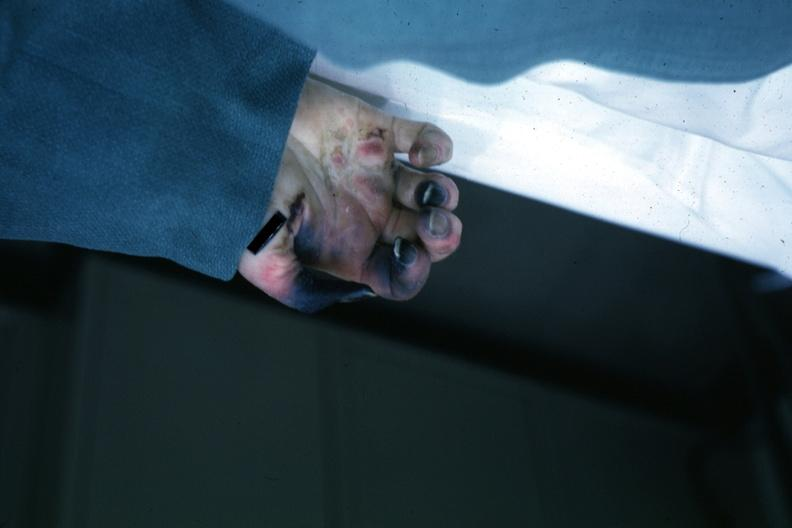does normal immature infant show obvious gangrenous necrosis due to shock or embolism postoperative cardiac surgery?
Answer the question using a single word or phrase. No 